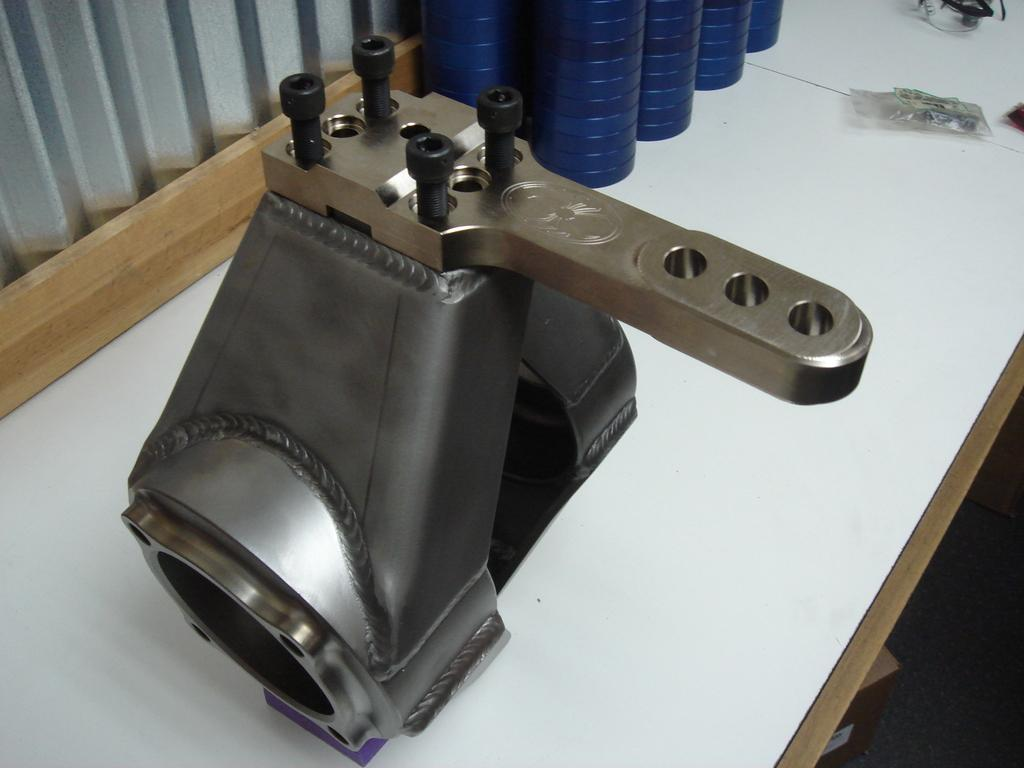What type of equipment can be seen in the image? There is an iron equipment in the image. What is located on the table in the image? There are bottles on a table in the image. What type of eggnog is being served on the floor in the image? There is no eggnog present in the image, and it is not being served on the floor. 